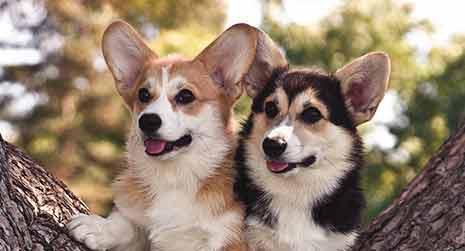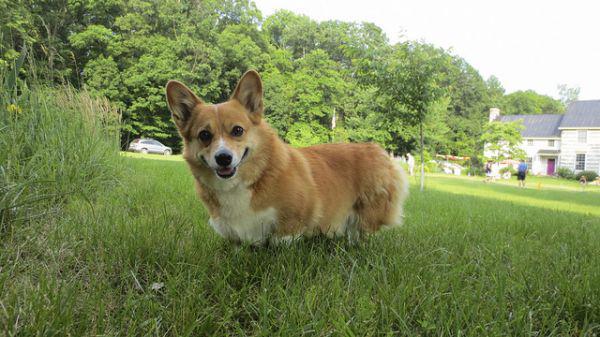The first image is the image on the left, the second image is the image on the right. Considering the images on both sides, is "An image shows a corgi standing in grass with leftward foot raised." valid? Answer yes or no. No. 